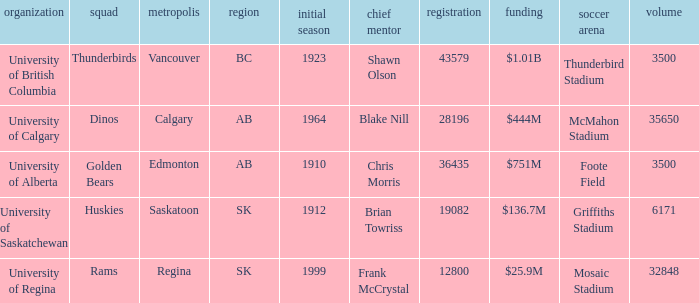How many endowments does Mosaic Stadium have? 1.0. 